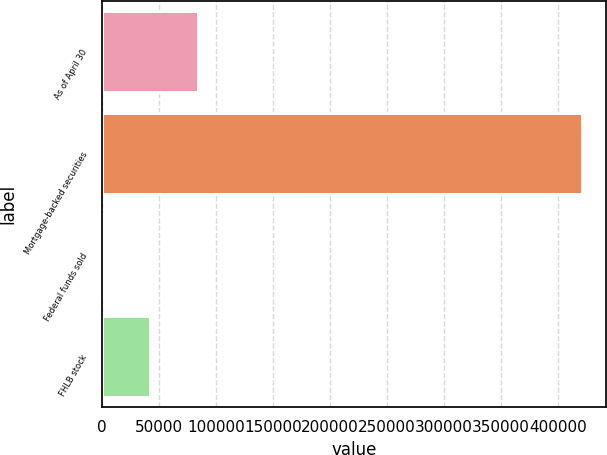Convert chart to OTSL. <chart><loc_0><loc_0><loc_500><loc_500><bar_chart><fcel>As of April 30<fcel>Mortgage-backed securities<fcel>Federal funds sold<fcel>FHLB stock<nl><fcel>84415.8<fcel>421035<fcel>261<fcel>42338.4<nl></chart> 